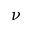<formula> <loc_0><loc_0><loc_500><loc_500>\nu</formula> 